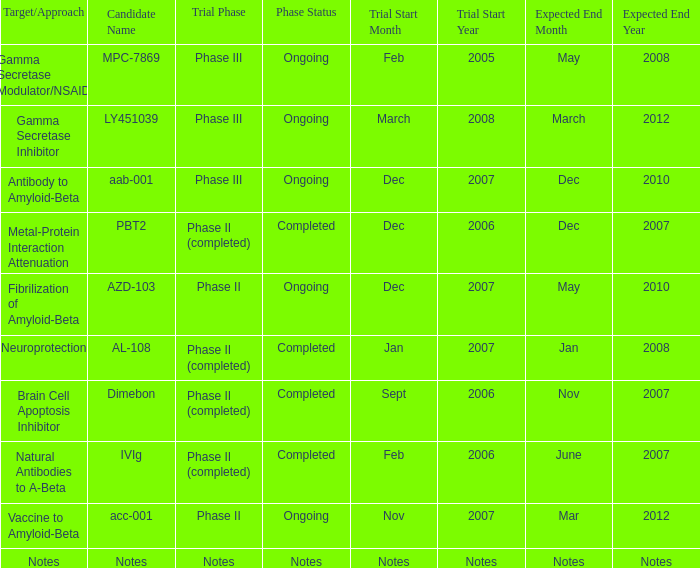What is Expected End Date, when Target/Approach is Notes? Notes. 